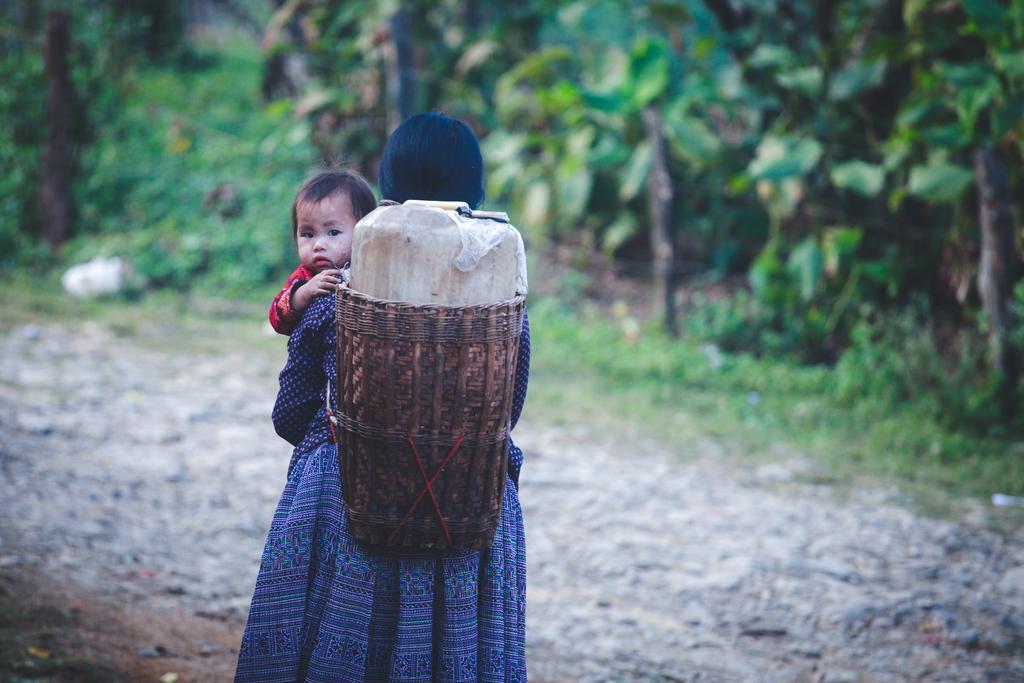How would you summarize this image in a sentence or two? In this image we can see a woman carrying a child wearing a basket on her back. On the backside we can see some grass and the trees. 